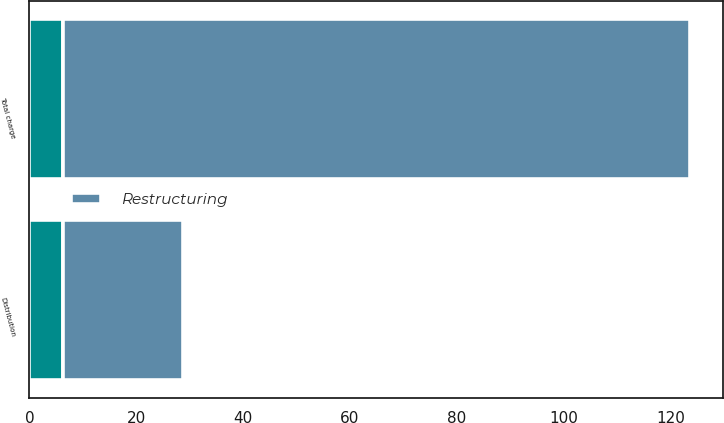<chart> <loc_0><loc_0><loc_500><loc_500><stacked_bar_chart><ecel><fcel>Distribution<fcel>Total charge<nl><fcel>nan<fcel>6.2<fcel>6.2<nl><fcel>Restructuring<fcel>22.6<fcel>117.4<nl></chart> 